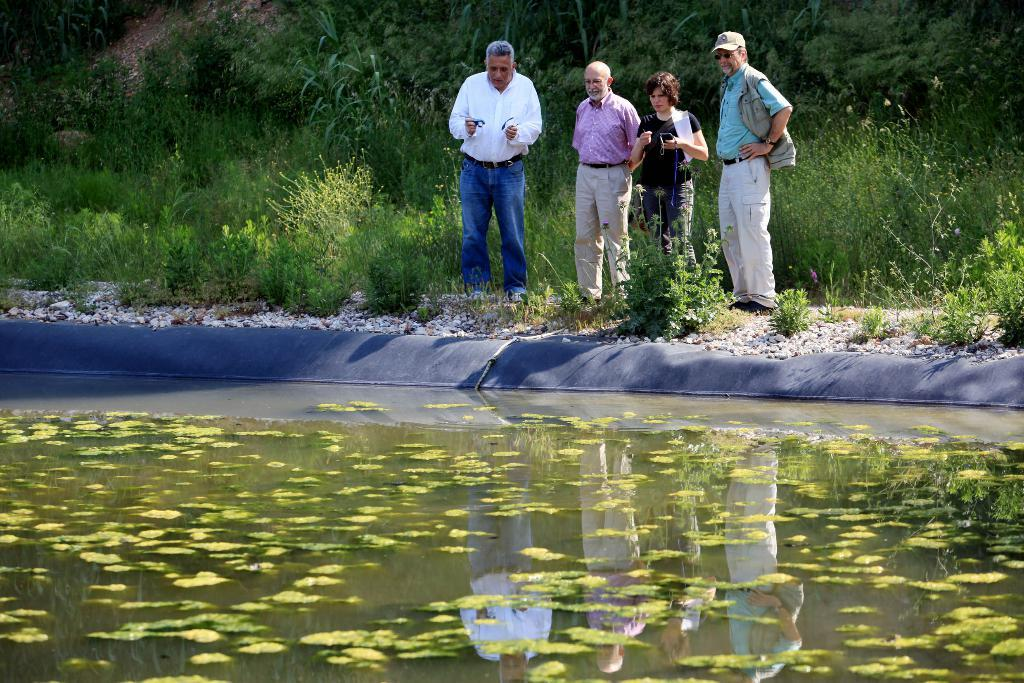What are the people in the image doing? The people in the image are standing on the ground. What type of natural elements can be seen in the image? Stones, leaves floating on water, trees, and plants are visible in the image. What is the background of the image composed of? The background of the image includes trees and plants. What type of shoe is floating on the water in the image? There is no shoe visible in the image; only leaves are floating on the water. Can you describe the face of the person in the image? There is no person's face visible in the image; only their bodies are shown while standing on the ground. 